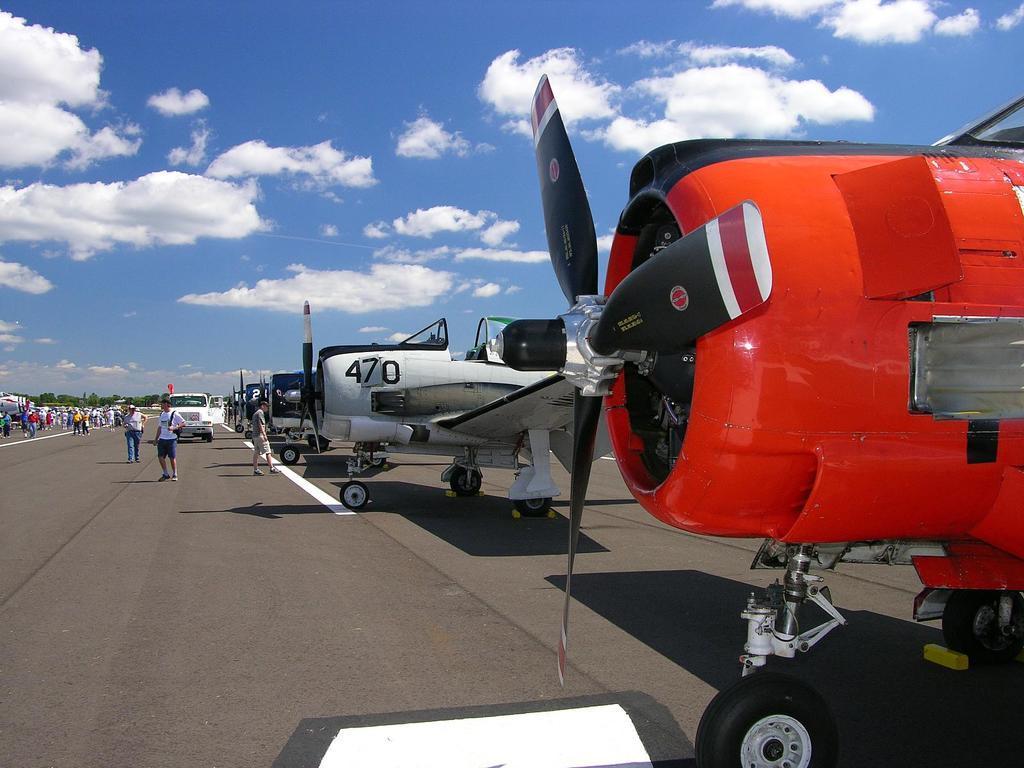Could you give a brief overview of what you see in this image? In this image we can see a few airplanes and the vehicle on the ground, there are some trees and people, in the background we can see the sky with clouds. 